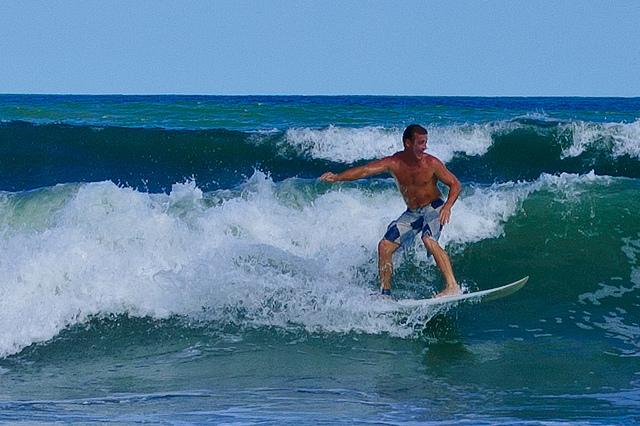Is this a man or woman?
Concise answer only. Man. Is the wave high?
Give a very brief answer. No. Is the surfer wearing a shirt?
Write a very short answer. No. Is the surfer good at the sport?
Concise answer only. Yes. What color is the water?
Concise answer only. Blue. 